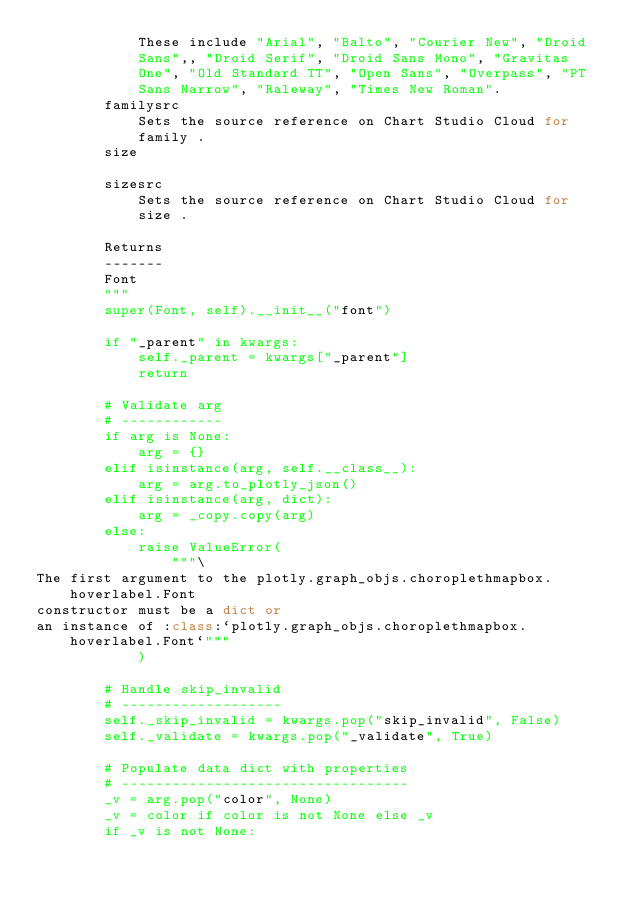Convert code to text. <code><loc_0><loc_0><loc_500><loc_500><_Python_>            These include "Arial", "Balto", "Courier New", "Droid
            Sans",, "Droid Serif", "Droid Sans Mono", "Gravitas
            One", "Old Standard TT", "Open Sans", "Overpass", "PT
            Sans Narrow", "Raleway", "Times New Roman".
        familysrc
            Sets the source reference on Chart Studio Cloud for
            family .
        size

        sizesrc
            Sets the source reference on Chart Studio Cloud for
            size .

        Returns
        -------
        Font
        """
        super(Font, self).__init__("font")

        if "_parent" in kwargs:
            self._parent = kwargs["_parent"]
            return

        # Validate arg
        # ------------
        if arg is None:
            arg = {}
        elif isinstance(arg, self.__class__):
            arg = arg.to_plotly_json()
        elif isinstance(arg, dict):
            arg = _copy.copy(arg)
        else:
            raise ValueError(
                """\
The first argument to the plotly.graph_objs.choroplethmapbox.hoverlabel.Font 
constructor must be a dict or 
an instance of :class:`plotly.graph_objs.choroplethmapbox.hoverlabel.Font`"""
            )

        # Handle skip_invalid
        # -------------------
        self._skip_invalid = kwargs.pop("skip_invalid", False)
        self._validate = kwargs.pop("_validate", True)

        # Populate data dict with properties
        # ----------------------------------
        _v = arg.pop("color", None)
        _v = color if color is not None else _v
        if _v is not None:</code> 